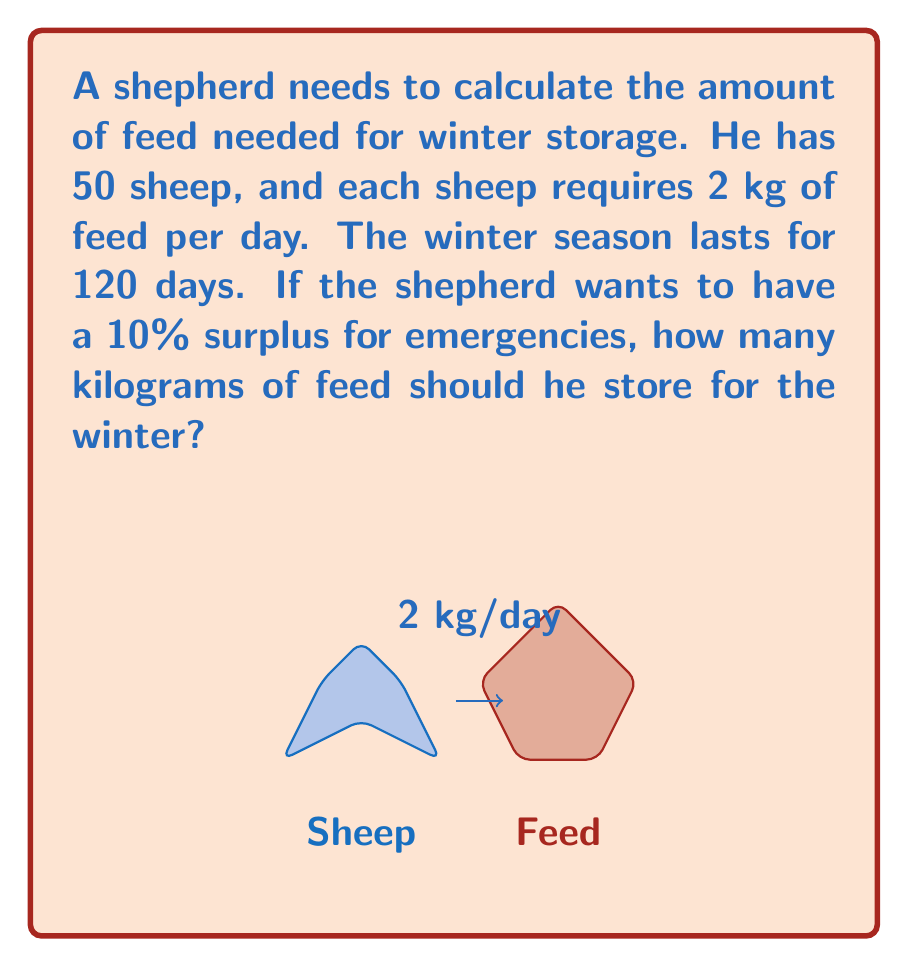Give your solution to this math problem. Let's break this problem down step by step:

1) First, calculate the daily feed requirement for all sheep:
   $$ \text{Daily feed} = 50 \text{ sheep} \times 2 \text{ kg/sheep} = 100 \text{ kg/day} $$

2) Now, calculate the total feed needed for the winter season:
   $$ \text{Winter feed} = 100 \text{ kg/day} \times 120 \text{ days} = 12,000 \text{ kg} $$

3) The shepherd wants a 10% surplus. To calculate this, we need to increase the amount by 10%:
   $$ \text{Surplus} = 12,000 \text{ kg} \times 0.10 = 1,200 \text{ kg} $$

4) Add the surplus to the winter feed amount:
   $$ \text{Total feed} = 12,000 \text{ kg} + 1,200 \text{ kg} = 13,200 \text{ kg} $$

Therefore, the shepherd should store 13,200 kg of feed for the winter.
Answer: 13,200 kg 